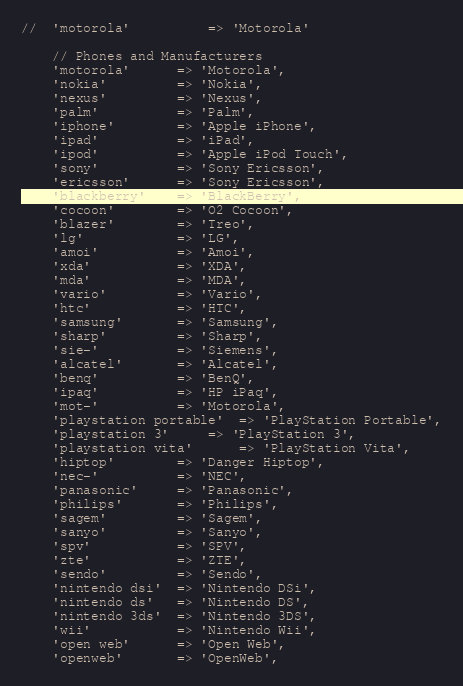Convert code to text. <code><loc_0><loc_0><loc_500><loc_500><_PHP_>//	'motorola'			=> 'Motorola'

	// Phones and Manufacturers
	'motorola'		=> 'Motorola',
	'nokia'			=> 'Nokia',
	'nexus'			=> 'Nexus',
	'palm'			=> 'Palm',
	'iphone'		=> 'Apple iPhone',
	'ipad'			=> 'iPad',
	'ipod'			=> 'Apple iPod Touch',
	'sony'			=> 'Sony Ericsson',
	'ericsson'		=> 'Sony Ericsson',
	'blackberry'	=> 'BlackBerry',
	'cocoon'		=> 'O2 Cocoon',
	'blazer'		=> 'Treo',
	'lg'			=> 'LG',
	'amoi'			=> 'Amoi',
	'xda'			=> 'XDA',
	'mda'			=> 'MDA',
	'vario'			=> 'Vario',
	'htc'			=> 'HTC',
	'samsung'		=> 'Samsung',
	'sharp'			=> 'Sharp',
	'sie-'			=> 'Siemens',
	'alcatel'		=> 'Alcatel',
	'benq'			=> 'BenQ',
	'ipaq'			=> 'HP iPaq',
	'mot-'			=> 'Motorola',
	'playstation portable'	=> 'PlayStation Portable',
	'playstation 3'		=> 'PlayStation 3',
	'playstation vita'  	=> 'PlayStation Vita',
	'hiptop'		=> 'Danger Hiptop',
	'nec-'			=> 'NEC',
	'panasonic'		=> 'Panasonic',
	'philips'		=> 'Philips',
	'sagem'			=> 'Sagem',
	'sanyo'			=> 'Sanyo',
	'spv'			=> 'SPV',
	'zte'			=> 'ZTE',
	'sendo'			=> 'Sendo',
	'nintendo dsi'	=> 'Nintendo DSi',
	'nintendo ds'	=> 'Nintendo DS',
	'nintendo 3ds'	=> 'Nintendo 3DS',
	'wii'			=> 'Nintendo Wii',
	'open web'		=> 'Open Web',
	'openweb'		=> 'OpenWeb',</code> 